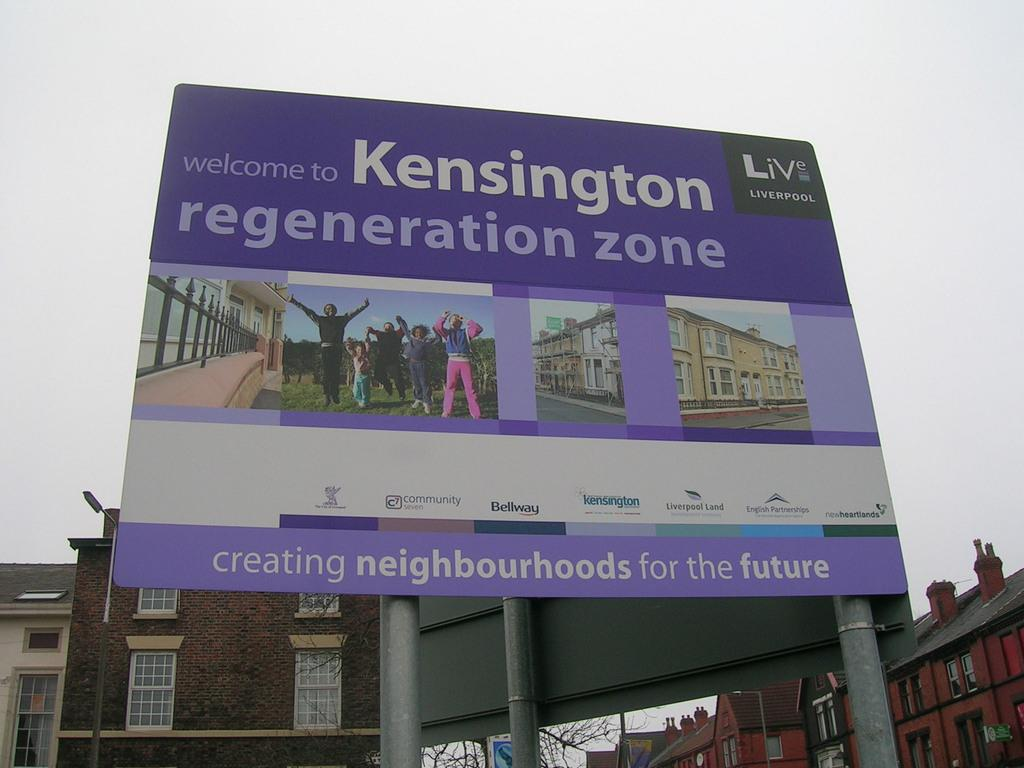Provide a one-sentence caption for the provided image. A large purple welcome sign to the kensington regeneration zone. 